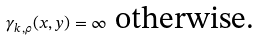<formula> <loc_0><loc_0><loc_500><loc_500>\gamma _ { k , \rho } ( x , y ) = \infty \text { otherwise.}</formula> 